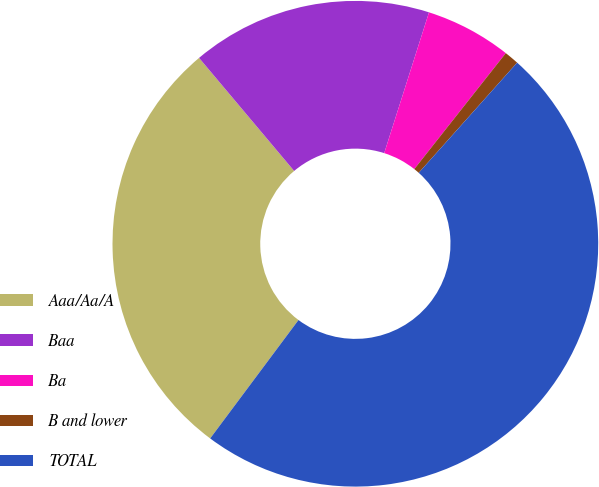Convert chart to OTSL. <chart><loc_0><loc_0><loc_500><loc_500><pie_chart><fcel>Aaa/Aa/A<fcel>Baa<fcel>Ba<fcel>B and lower<fcel>TOTAL<nl><fcel>28.67%<fcel>16.03%<fcel>5.73%<fcel>0.97%<fcel>48.59%<nl></chart> 